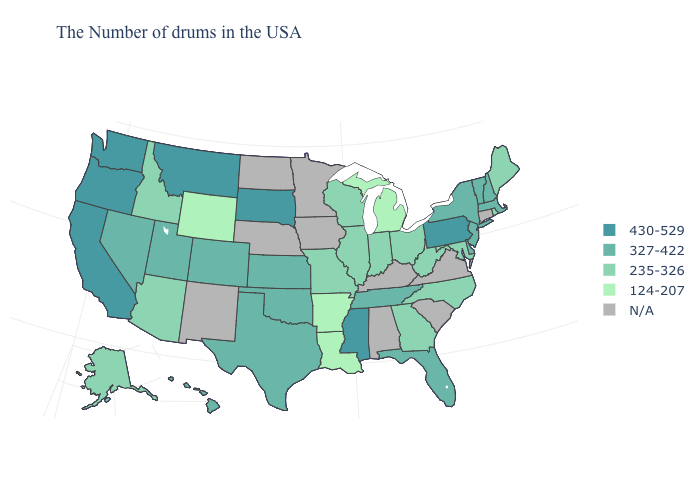Which states have the highest value in the USA?
Write a very short answer. Pennsylvania, Mississippi, South Dakota, Montana, California, Washington, Oregon. What is the value of Connecticut?
Keep it brief. N/A. Name the states that have a value in the range 327-422?
Quick response, please. Massachusetts, New Hampshire, Vermont, New York, New Jersey, Delaware, Florida, Tennessee, Kansas, Oklahoma, Texas, Colorado, Utah, Nevada, Hawaii. What is the highest value in the USA?
Quick response, please. 430-529. What is the value of Wisconsin?
Write a very short answer. 235-326. Is the legend a continuous bar?
Write a very short answer. No. What is the value of Mississippi?
Be succinct. 430-529. Among the states that border Utah , does Arizona have the highest value?
Be succinct. No. Among the states that border Washington , which have the lowest value?
Be succinct. Idaho. Name the states that have a value in the range 124-207?
Quick response, please. Michigan, Louisiana, Arkansas, Wyoming. Which states have the highest value in the USA?
Short answer required. Pennsylvania, Mississippi, South Dakota, Montana, California, Washington, Oregon. What is the lowest value in the USA?
Be succinct. 124-207. Which states hav the highest value in the MidWest?
Be succinct. South Dakota. Name the states that have a value in the range N/A?
Keep it brief. Connecticut, Virginia, South Carolina, Kentucky, Alabama, Minnesota, Iowa, Nebraska, North Dakota, New Mexico. 